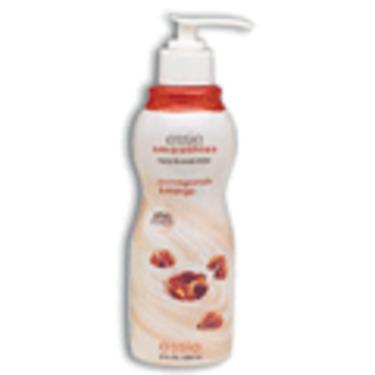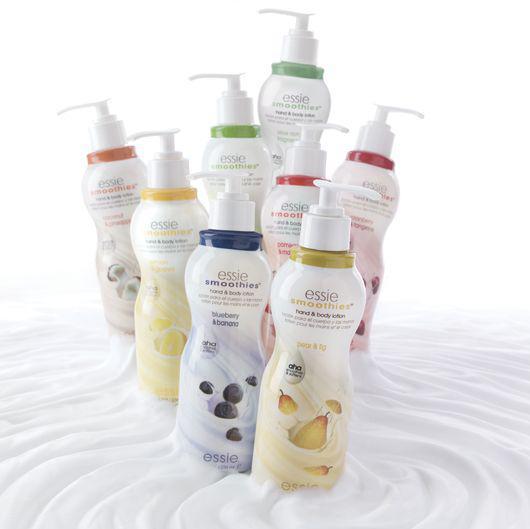The first image is the image on the left, the second image is the image on the right. Evaluate the accuracy of this statement regarding the images: "The left and right image contains the same number of soaps and lotions.". Is it true? Answer yes or no. No. The first image is the image on the left, the second image is the image on the right. Given the left and right images, does the statement "All skincare items shown have pump dispensers, and at least one image contains only one skincare item." hold true? Answer yes or no. Yes. 